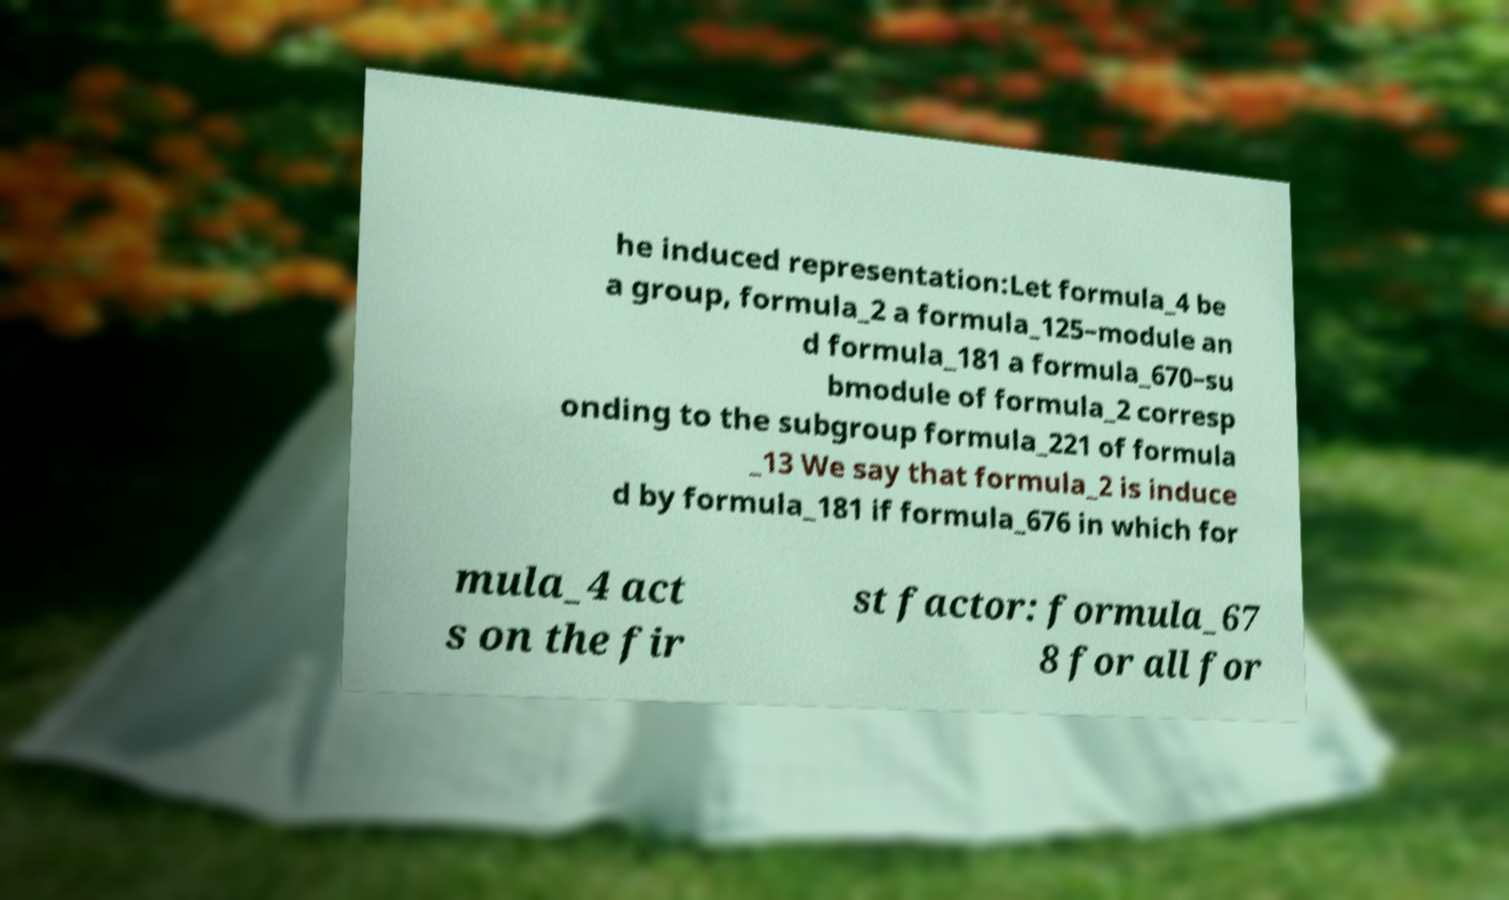Can you accurately transcribe the text from the provided image for me? he induced representation:Let formula_4 be a group, formula_2 a formula_125–module an d formula_181 a formula_670–su bmodule of formula_2 corresp onding to the subgroup formula_221 of formula _13 We say that formula_2 is induce d by formula_181 if formula_676 in which for mula_4 act s on the fir st factor: formula_67 8 for all for 